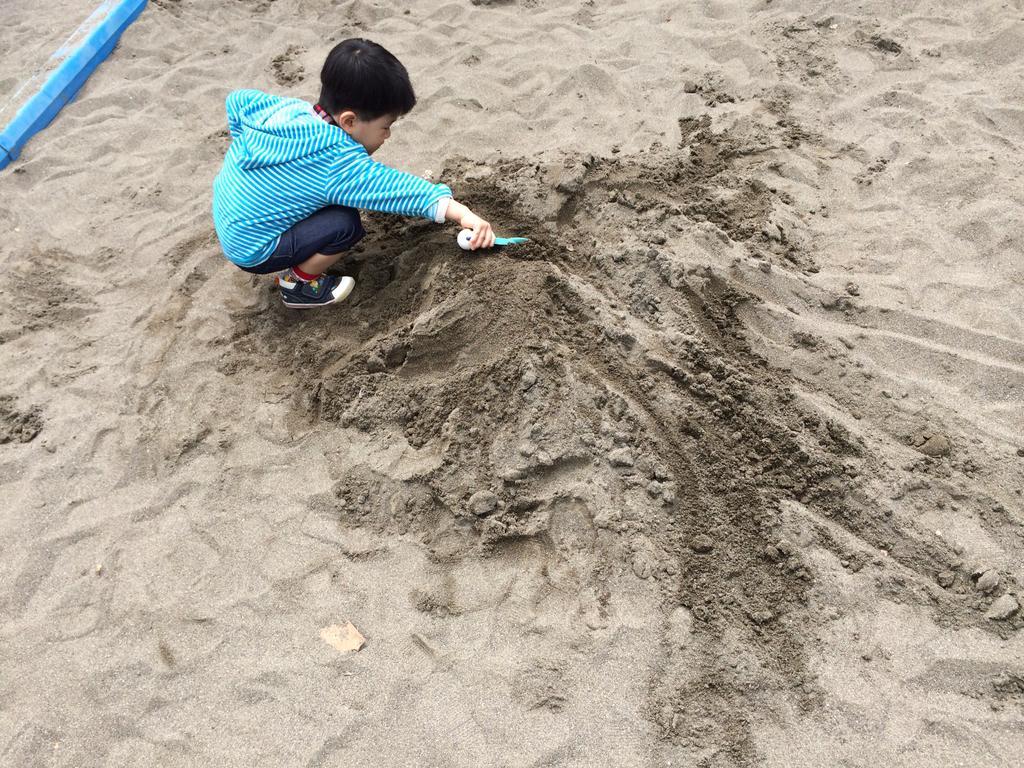Could you give a brief overview of what you see in this image? A boy is playing with the sand, he wore blue color sweater, black color shoes. 